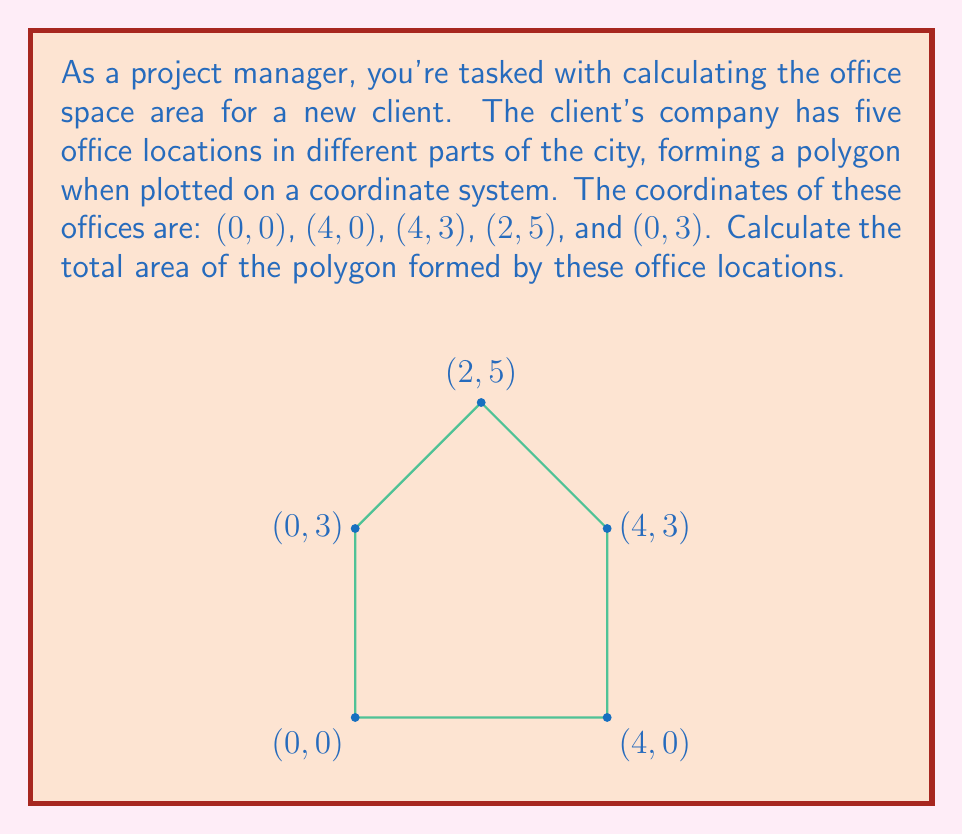Teach me how to tackle this problem. To calculate the area of this irregular polygon, we can use the Shoelace formula (also known as the surveyor's formula). This method works for any polygon given the coordinates of its vertices.

The Shoelace formula is:

$$A = \frac{1}{2}|\sum_{i=1}^{n-1} (x_i y_{i+1} + x_n y_1) - \sum_{i=1}^{n-1} (y_i x_{i+1} + y_n x_1)|$$

Where $(x_i, y_i)$ are the coordinates of the $i$-th vertex.

Let's apply this formula to our polygon:

1) First, let's list our coordinates in order:
   $(x_1, y_1) = (0, 0)$
   $(x_2, y_2) = (4, 0)$
   $(x_3, y_3) = (4, 3)$
   $(x_4, y_4) = (2, 5)$
   $(x_5, y_5) = (0, 3)$

2) Now, let's calculate the first sum:
   $\sum_{i=1}^{n-1} (x_i y_{i+1} + x_n y_1)$
   $= (0 \cdot 0 + 4 \cdot 3 + 4 \cdot 5 + 2 \cdot 3 + 0 \cdot 0)$
   $= 0 + 12 + 20 + 6 + 0 = 38$

3) Next, calculate the second sum:
   $\sum_{i=1}^{n-1} (y_i x_{i+1} + y_n x_1)$
   $= (0 \cdot 4 + 0 \cdot 4 + 3 \cdot 2 + 5 \cdot 0 + 3 \cdot 0)$
   $= 0 + 0 + 6 + 0 + 0 = 6$

4) Now, subtract the second sum from the first and take the absolute value:
   $|38 - 6| = 32$

5) Finally, divide by 2:
   $\frac{32}{2} = 16$

Therefore, the area of the polygon is 16 square units.
Answer: The area of the polygon formed by the office locations is 16 square units. 